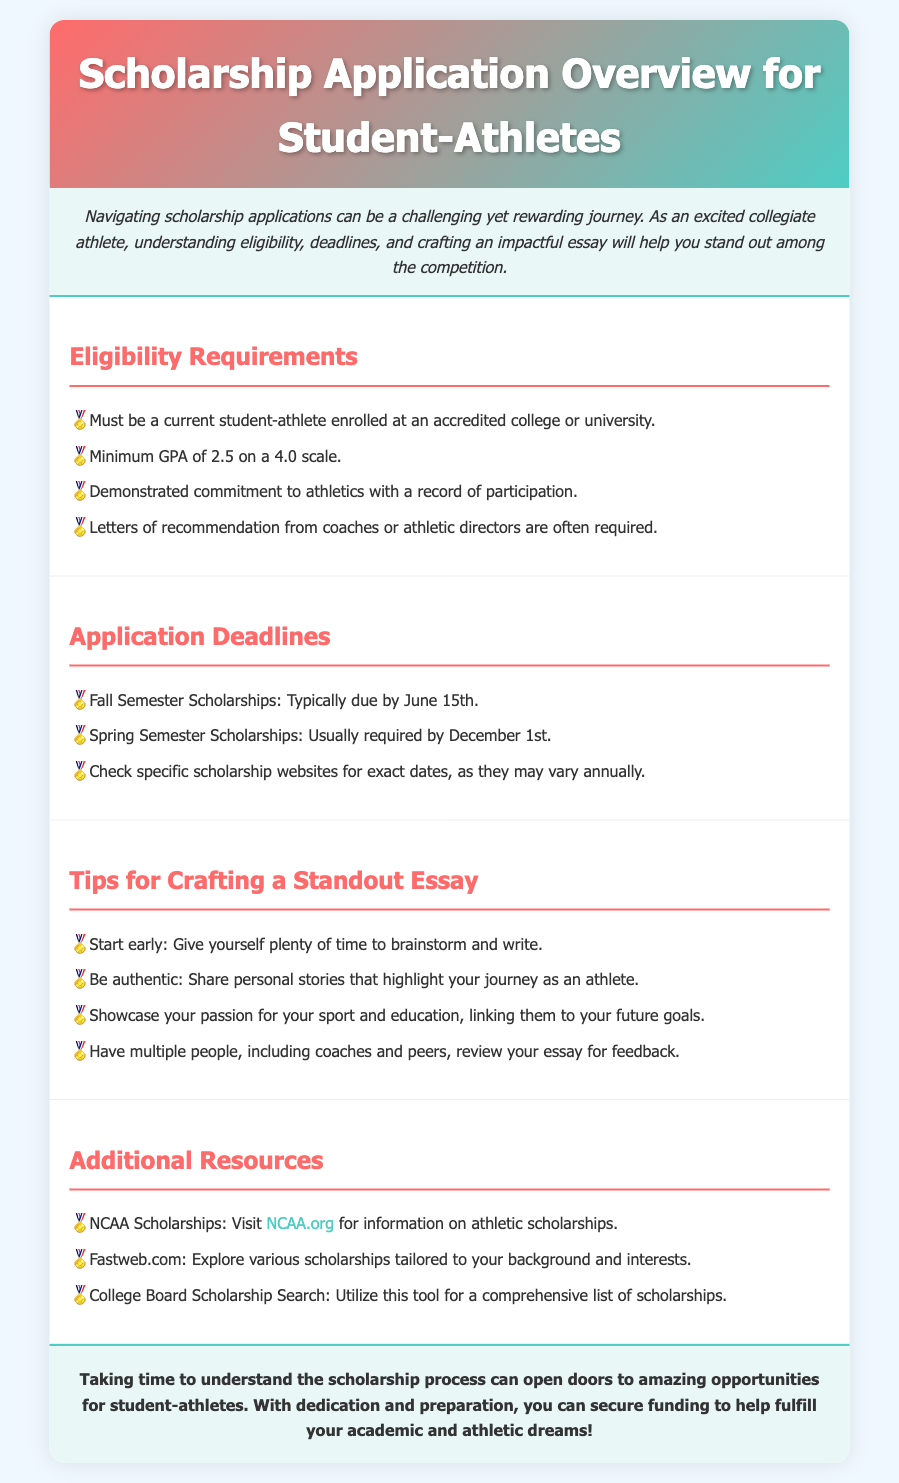What is the minimum GPA required for scholarship eligibility? The document states that a minimum GPA of 2.5 on a 4.0 scale is required for scholarship eligibility.
Answer: 2.5 When are Fall Semester Scholarships typically due? The document indicates that Fall Semester Scholarships are typically due by June 15th.
Answer: June 15th What type of letters are often required for scholarship applications? According to the document, letters of recommendation from coaches or athletic directors are often required.
Answer: Letters of recommendation What is one key tip for crafting a standout essay? The document suggests starting early and giving yourself plenty of time to brainstorm and write as a key tip for crafting a standout essay.
Answer: Start early What resource can be visited for information on athletic scholarships? The document mentions that NCAA.org can be visited for information on athletic scholarships.
Answer: NCAA.org What is the scholarship deadline for Fall semester applications? The document specifies that the typical deadline is June 15th for Fall semester applications.
Answer: June 15th Why is it important to have multiple people review your essay? The document implies it is important to have multiple reviews for feedback to improve the quality and impact of your essay.
Answer: Feedback What color is used for section headings in the document? The document states that section headings are colored in red (specifically #ff6b6b).
Answer: Red What opportunity do scholarships provide for student-athletes? The document highlights that scholarships can open doors to amazing opportunities for student-athletes.
Answer: Amazing opportunities 